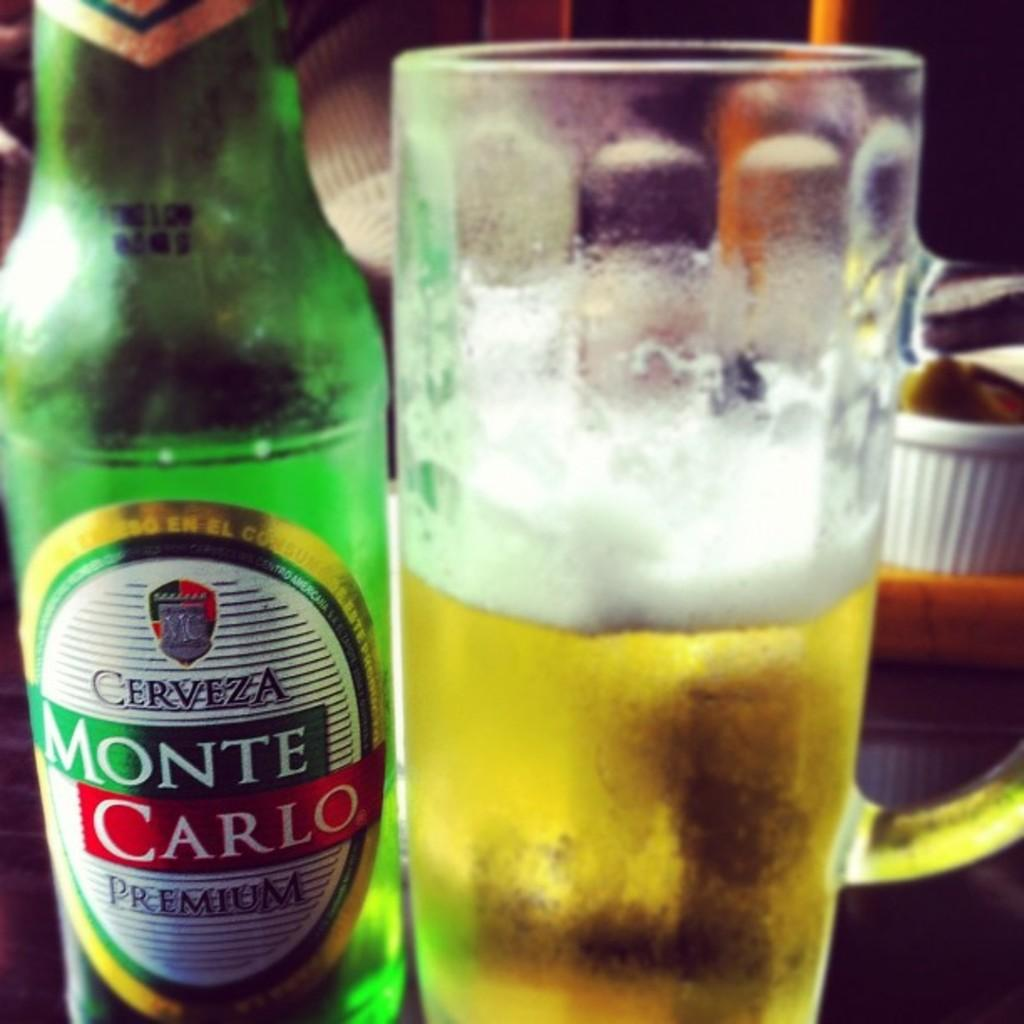What is in the glass that is visible in the image? There is a glass of drink in the image. What else can be seen on the left side of the image? There is a bottle on the left side of the image. What is written on the bottle? The bottle has "monte carlo" written on it. How many fans are visible in the image? There are no fans present in the image. Is there a masked person in the image? There is no masked person present in the image. 